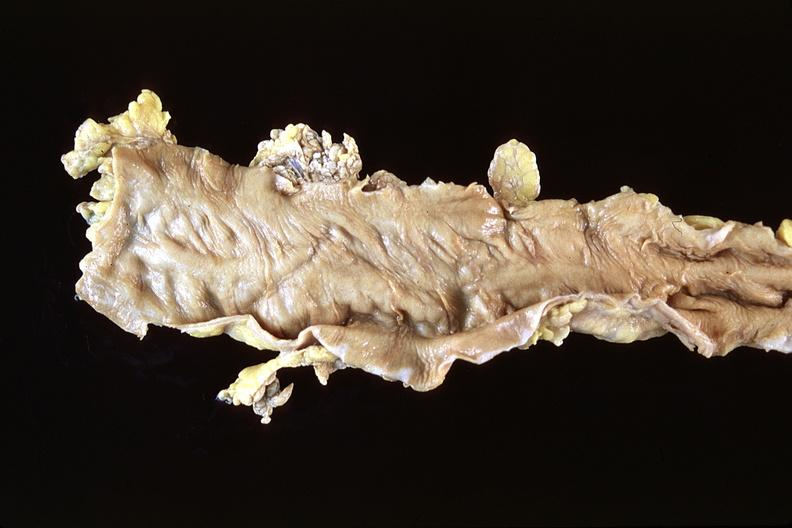does this image show normal colon?
Answer the question using a single word or phrase. Yes 